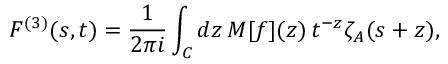<formula> <loc_0><loc_0><loc_500><loc_500>F ^ { ( 3 ) } ( s , t ) = \frac { 1 } { 2 \pi i } \int _ { C } d z \, M [ f ] ( z ) \, t ^ { - z } \zeta _ { A } ( s + z ) ,</formula> 